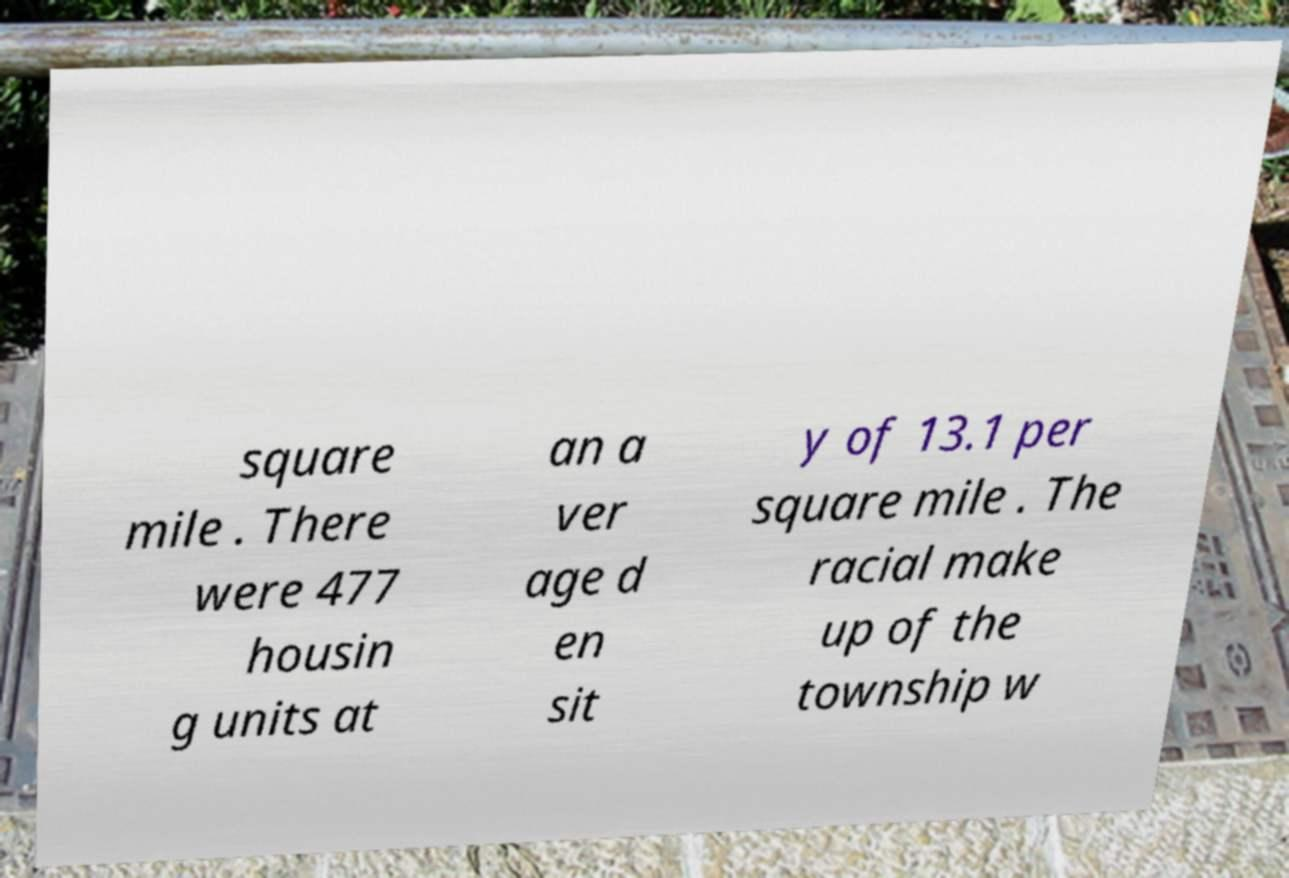Please read and relay the text visible in this image. What does it say? square mile . There were 477 housin g units at an a ver age d en sit y of 13.1 per square mile . The racial make up of the township w 